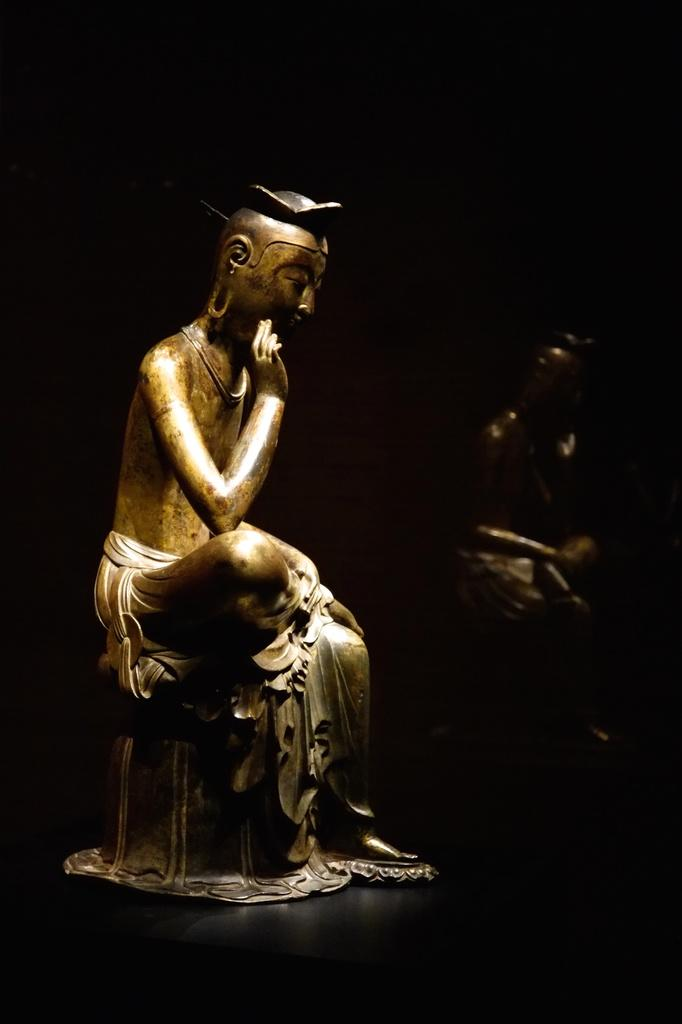What is the main subject in the center of the image? There is a statue in the center of the image. Where is the statue located? The statue is on the ground. Are there any other statues visible in the image? Yes, there is a statue visible in the background of the image. What is the size of the cord used to power the discussion in the image? There is no discussion or cord present in the image; it features two statues. 